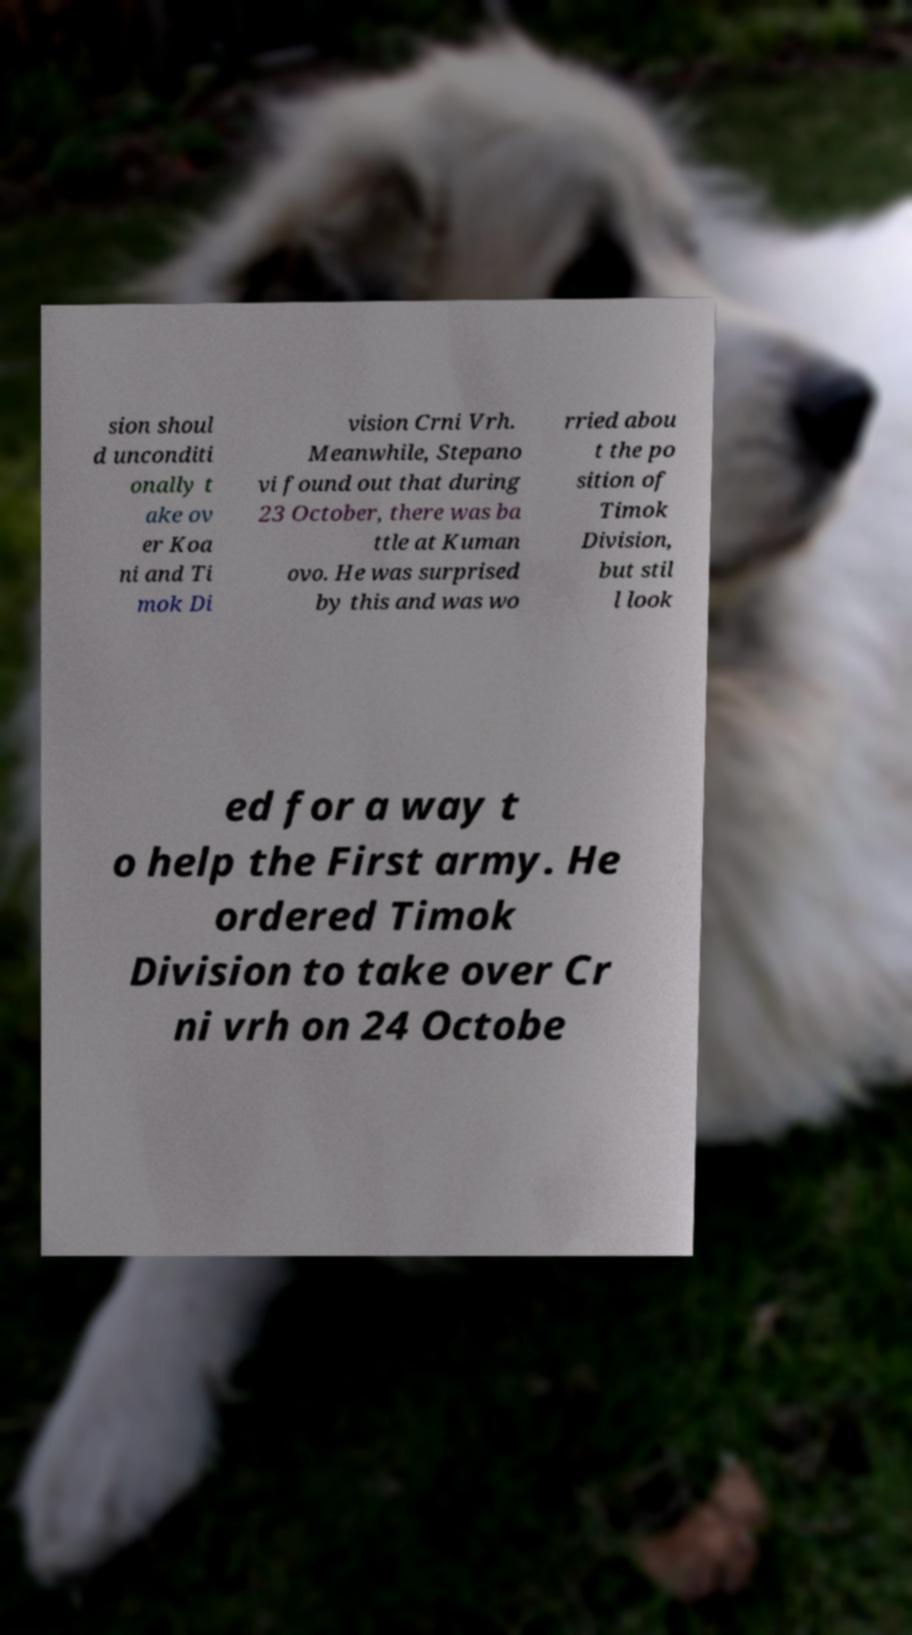Can you read and provide the text displayed in the image?This photo seems to have some interesting text. Can you extract and type it out for me? sion shoul d unconditi onally t ake ov er Koa ni and Ti mok Di vision Crni Vrh. Meanwhile, Stepano vi found out that during 23 October, there was ba ttle at Kuman ovo. He was surprised by this and was wo rried abou t the po sition of Timok Division, but stil l look ed for a way t o help the First army. He ordered Timok Division to take over Cr ni vrh on 24 Octobe 